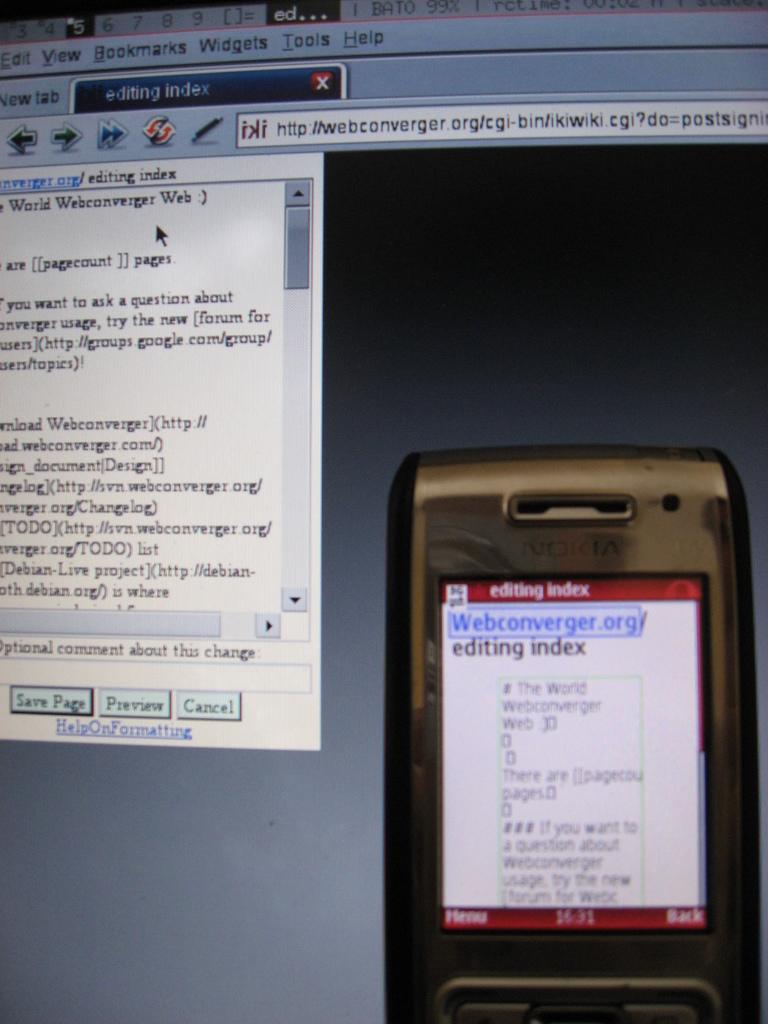What type of index is mentioned on the phone screen?
Make the answer very short. Editing. 